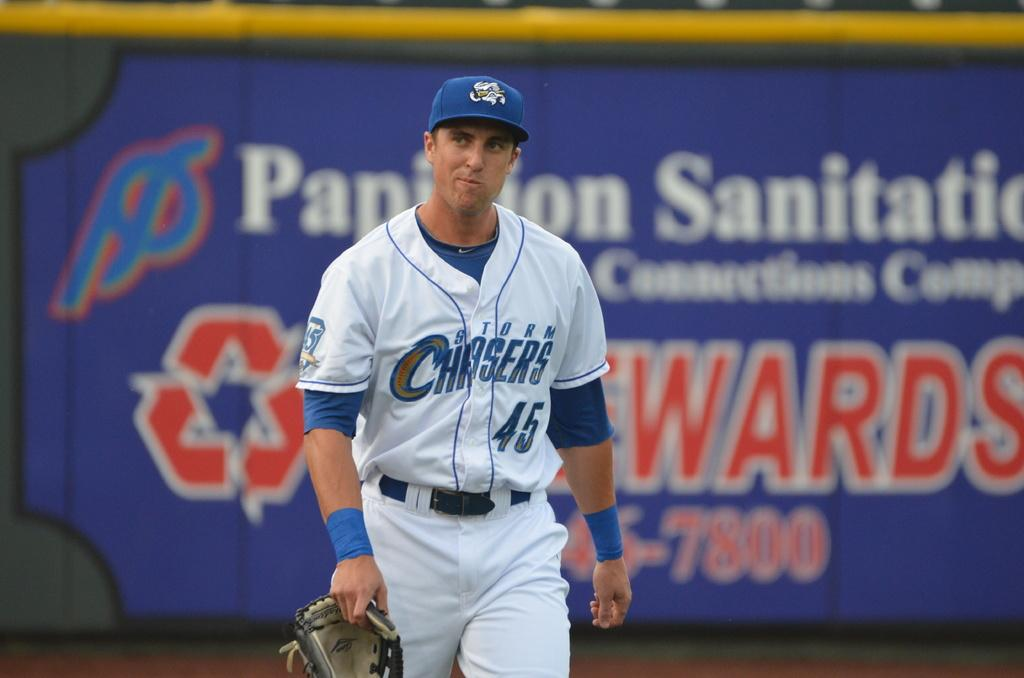<image>
Give a short and clear explanation of the subsequent image. The player's jersey with the number 45 in blue on the front of it. 